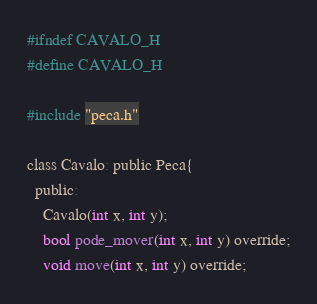<code> <loc_0><loc_0><loc_500><loc_500><_C_>#ifndef CAVALO_H
#define CAVALO_H

#include "peca.h"

class Cavalo: public Peca{
  public:
    Cavalo(int x, int y);
    bool pode_mover(int x, int y) override;
    void move(int x, int y) override;</code> 